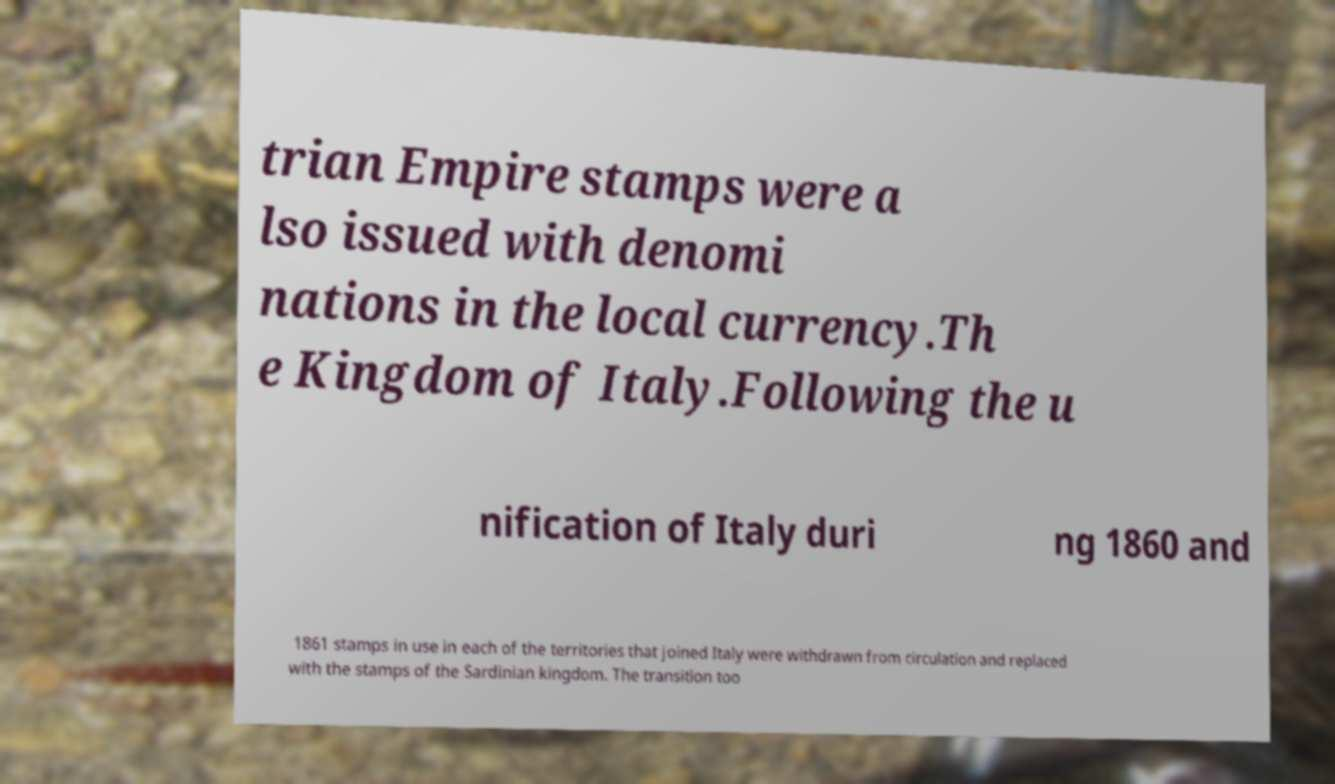There's text embedded in this image that I need extracted. Can you transcribe it verbatim? trian Empire stamps were a lso issued with denomi nations in the local currency.Th e Kingdom of Italy.Following the u nification of Italy duri ng 1860 and 1861 stamps in use in each of the territories that joined Italy were withdrawn from circulation and replaced with the stamps of the Sardinian kingdom. The transition too 